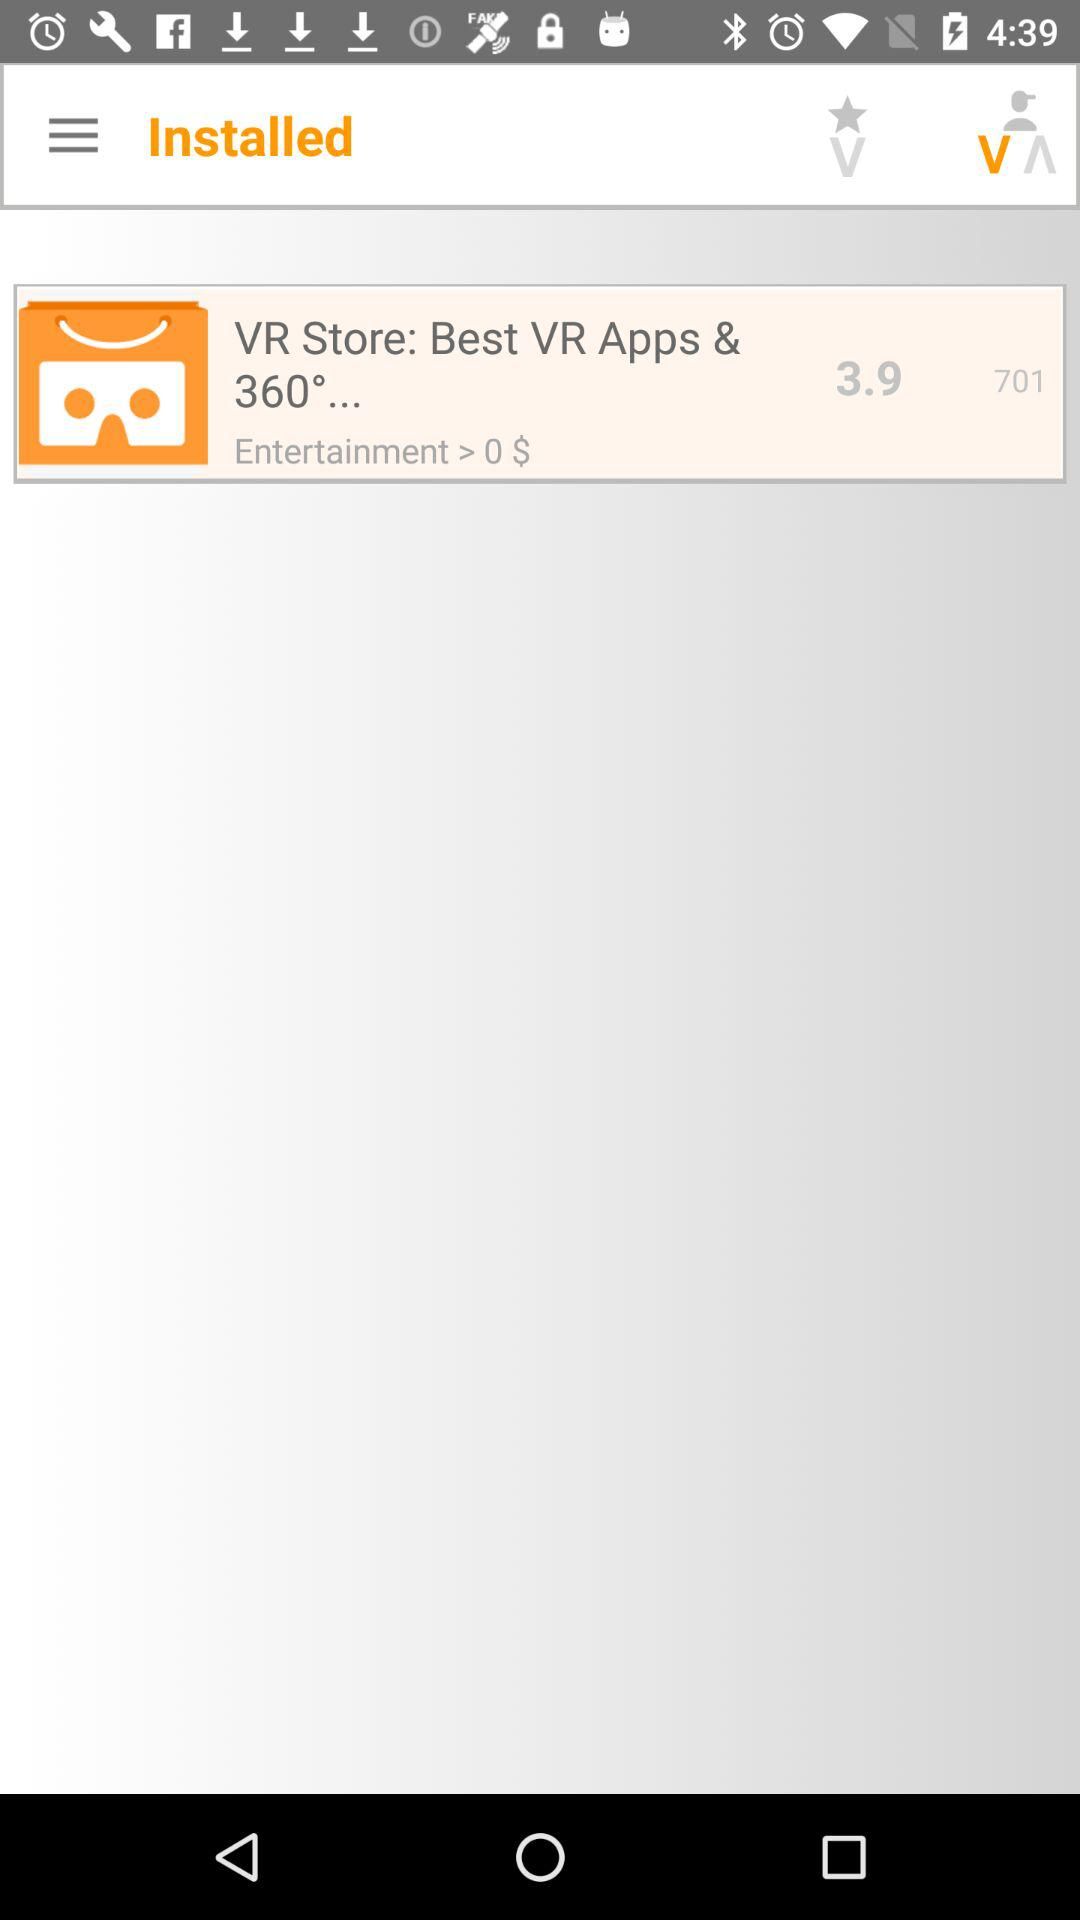What is the rating for the application? The rating for the application is 3.9. 